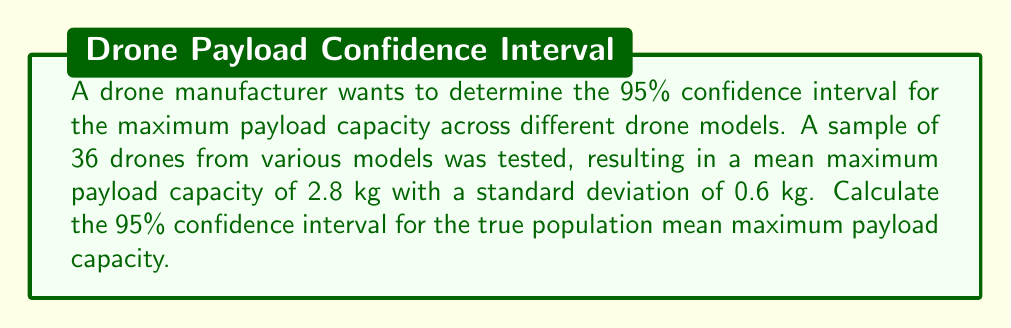Show me your answer to this math problem. To calculate the confidence interval, we'll follow these steps:

1. Identify the known values:
   - Sample size: $n = 36$
   - Sample mean: $\bar{x} = 2.8$ kg
   - Sample standard deviation: $s = 0.6$ kg
   - Confidence level: 95% (α = 0.05)

2. Determine the critical value:
   For a 95% confidence interval with df = 35, the t-critical value is approximately 2.030 (from t-distribution table).

3. Calculate the margin of error:
   Margin of error = $t_{\text{critical}} \cdot \frac{s}{\sqrt{n}}$
   $$ \text{Margin of error} = 2.030 \cdot \frac{0.6}{\sqrt{36}} = 2.030 \cdot 0.1 = 0.203 $$

4. Calculate the confidence interval:
   Lower bound = $\bar{x} - \text{Margin of error}$
   Upper bound = $\bar{x} + \text{Margin of error}$

   $$ \text{Lower bound} = 2.8 - 0.203 = 2.597 \text{ kg} $$
   $$ \text{Upper bound} = 2.8 + 0.203 = 3.003 \text{ kg} $$

5. Express the confidence interval:
   (2.597 kg, 3.003 kg)
Answer: (2.597 kg, 3.003 kg) 